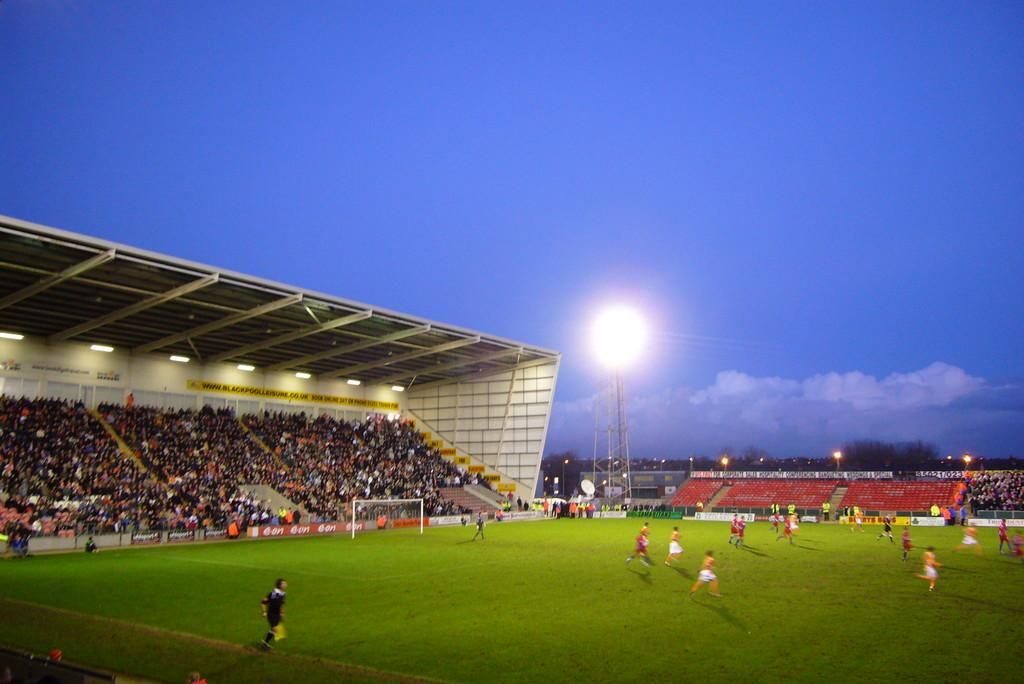How many people are in the image? There is a group of people in the image, but the exact number is not specified. What are some of the people in the image doing? Some people are seated, and some are playing a game on the ground. What objects can be seen in the image that are made of metal? There are metal rods in the image. What type of structure is present in the image? There is a tower in the image. What type of furniture is present in the image? There are chairs in the image. What type of natural elements can be seen in the image? There are trees in the image. What type of artificial lighting is present in the image? There are lights in the image. What type of smell can be detected from the coach in the image? There is no coach present in the image, so it is not possible to detect any smell. 